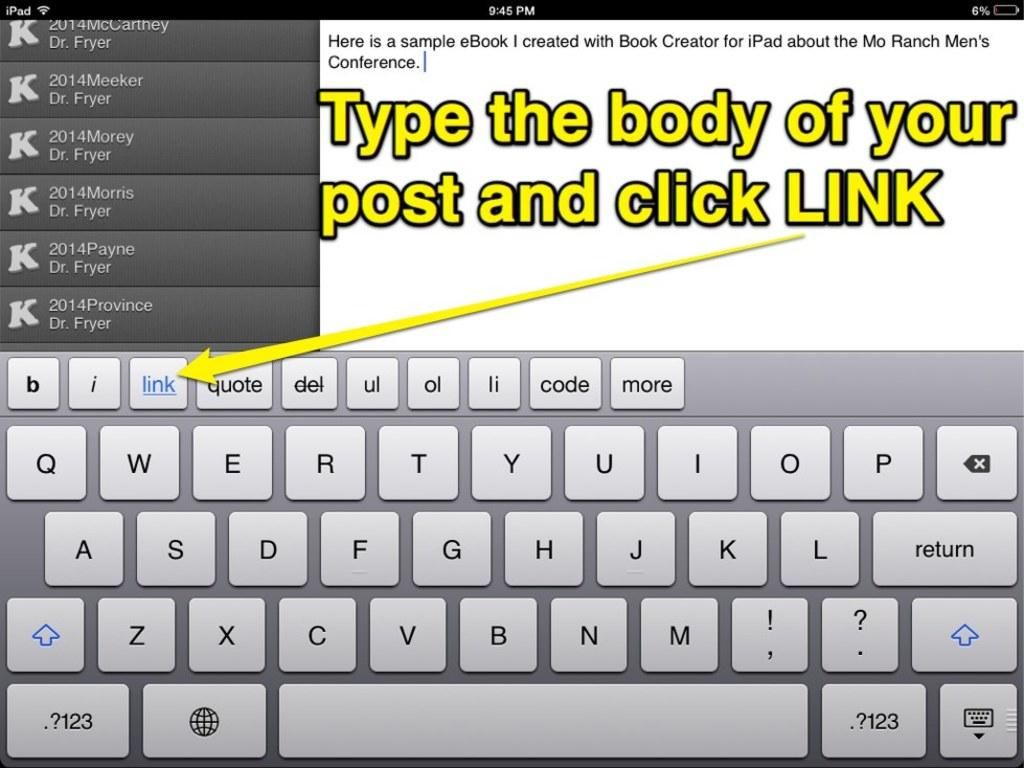<image>
Present a compact description of the photo's key features. A screen of an iPad that says type the body of your post and click link. 